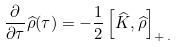Convert formula to latex. <formula><loc_0><loc_0><loc_500><loc_500>\frac { \partial } { \partial \tau } \widehat { \rho } ( \tau ) = - \frac { 1 } { 2 } \left [ \widehat { K } , \widehat { \rho } \right ] _ { + \, . }</formula> 